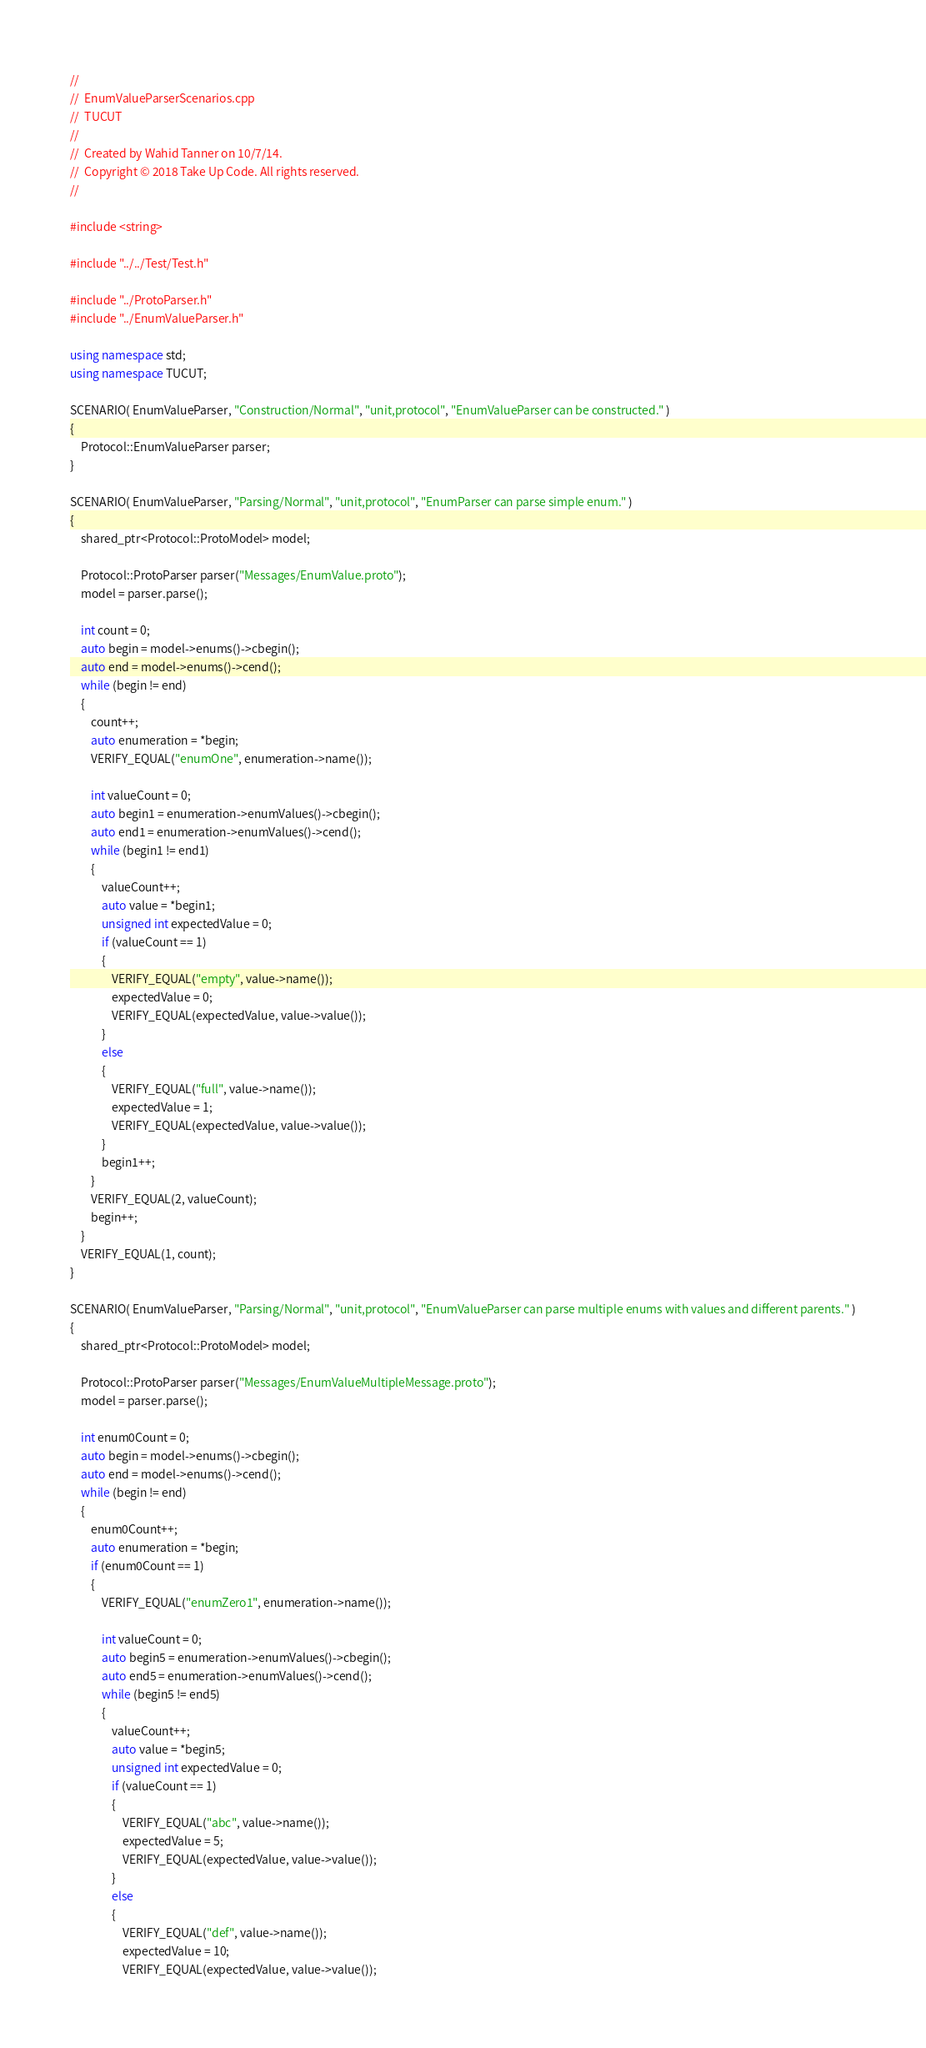Convert code to text. <code><loc_0><loc_0><loc_500><loc_500><_C++_>//
//  EnumValueParserScenarios.cpp
//  TUCUT
//
//  Created by Wahid Tanner on 10/7/14.
//  Copyright © 2018 Take Up Code. All rights reserved.
//

#include <string>

#include "../../Test/Test.h"

#include "../ProtoParser.h"
#include "../EnumValueParser.h"

using namespace std;
using namespace TUCUT;

SCENARIO( EnumValueParser, "Construction/Normal", "unit,protocol", "EnumValueParser can be constructed." )
{
    Protocol::EnumValueParser parser;
}

SCENARIO( EnumValueParser, "Parsing/Normal", "unit,protocol", "EnumParser can parse simple enum." )
{
    shared_ptr<Protocol::ProtoModel> model;

    Protocol::ProtoParser parser("Messages/EnumValue.proto");
    model = parser.parse();

    int count = 0;
    auto begin = model->enums()->cbegin();
    auto end = model->enums()->cend();
    while (begin != end)
    {
        count++;
        auto enumeration = *begin;
        VERIFY_EQUAL("enumOne", enumeration->name());

        int valueCount = 0;
        auto begin1 = enumeration->enumValues()->cbegin();
        auto end1 = enumeration->enumValues()->cend();
        while (begin1 != end1)
        {
            valueCount++;
            auto value = *begin1;
            unsigned int expectedValue = 0;
            if (valueCount == 1)
            {
                VERIFY_EQUAL("empty", value->name());
                expectedValue = 0;
                VERIFY_EQUAL(expectedValue, value->value());
            }
            else
            {
                VERIFY_EQUAL("full", value->name());
                expectedValue = 1;
                VERIFY_EQUAL(expectedValue, value->value());
            }
            begin1++;
        }
        VERIFY_EQUAL(2, valueCount);
        begin++;
    }
    VERIFY_EQUAL(1, count);
}

SCENARIO( EnumValueParser, "Parsing/Normal", "unit,protocol", "EnumValueParser can parse multiple enums with values and different parents." )
{
    shared_ptr<Protocol::ProtoModel> model;

    Protocol::ProtoParser parser("Messages/EnumValueMultipleMessage.proto");
    model = parser.parse();

    int enum0Count = 0;
    auto begin = model->enums()->cbegin();
    auto end = model->enums()->cend();
    while (begin != end)
    {
        enum0Count++;
        auto enumeration = *begin;
        if (enum0Count == 1)
        {
            VERIFY_EQUAL("enumZero1", enumeration->name());

            int valueCount = 0;
            auto begin5 = enumeration->enumValues()->cbegin();
            auto end5 = enumeration->enumValues()->cend();
            while (begin5 != end5)
            {
                valueCount++;
                auto value = *begin5;
                unsigned int expectedValue = 0;
                if (valueCount == 1)
                {
                    VERIFY_EQUAL("abc", value->name());
                    expectedValue = 5;
                    VERIFY_EQUAL(expectedValue, value->value());
                }
                else
                {
                    VERIFY_EQUAL("def", value->name());
                    expectedValue = 10;
                    VERIFY_EQUAL(expectedValue, value->value());</code> 